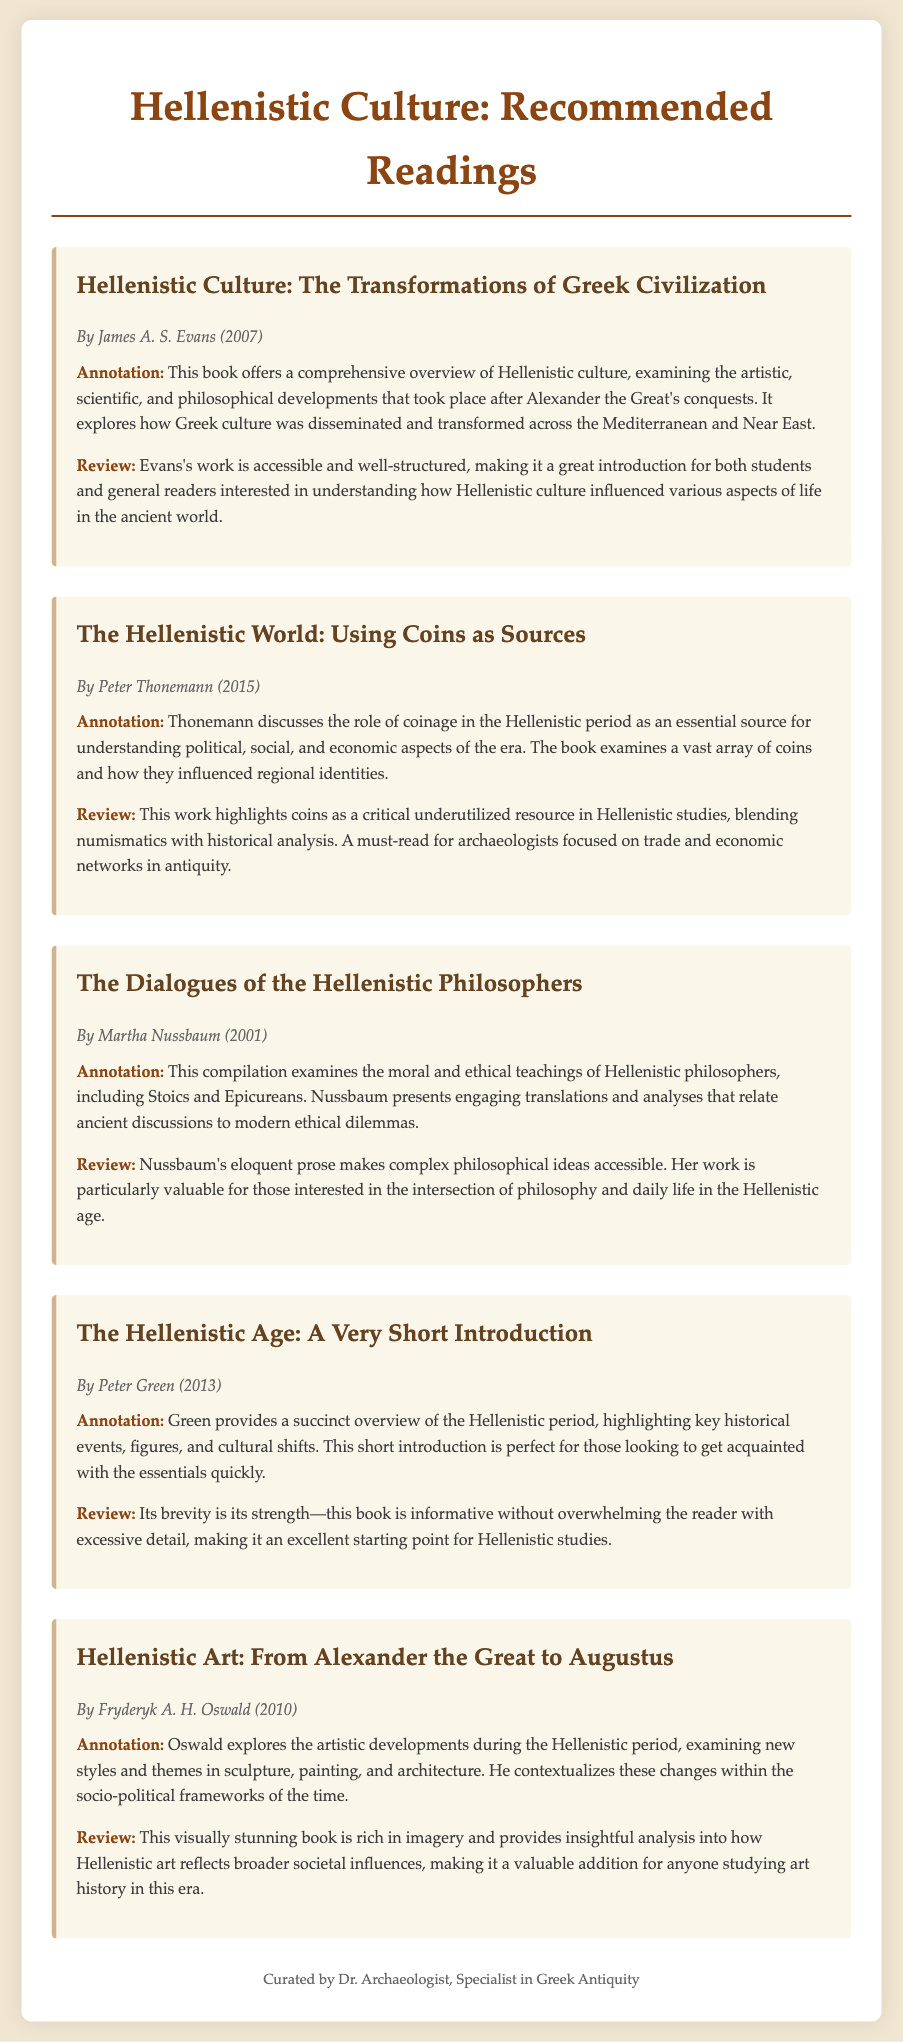What is the title of the first book? The title of the first book is mentioned prominently in the text.
Answer: Hellenistic Culture: The Transformations of Greek Civilization Who is the author of "The Hellenistic World: Using Coins as Sources"? The author's name is provided alongside the book title and publication information.
Answer: Peter Thonemann What year was "The Dialogues of the Hellenistic Philosophers" published? The publication year is indicated right after the author's name in the book section.
Answer: 2001 What is the main topic of the book by Fryderyk A. H. Oswald? The main topic is summarized in the annotation section of the book description.
Answer: Hellenistic Art Which book discusses the role of coinage? The question requires identifying the book that focuses on economic aspects as mentioned in the document.
Answer: The Hellenistic World: Using Coins as Sources How is "The Hellenistic Age: A Very Short Introduction" described in terms of length? This description is found in the review section, indicating the book's brevity and accessibility.
Answer: Short What type of sources does Thonemann emphasize in his book? The annotation section highlights the type of sources discussed in relation to the Hellenistic period.
Answer: Coins What is noted as a key strength of Peter Green's book? The review section clearly outlines a notable attribute of this particular work.
Answer: Brevity 